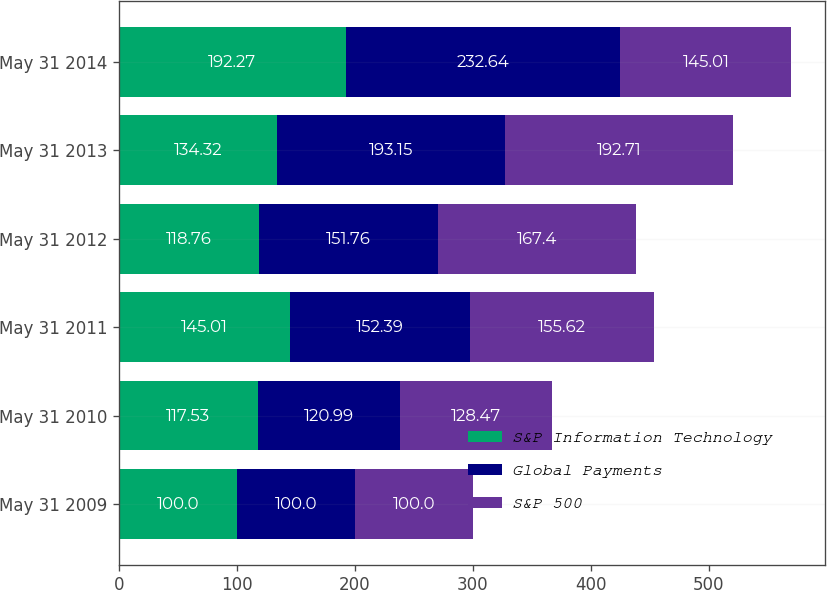<chart> <loc_0><loc_0><loc_500><loc_500><stacked_bar_chart><ecel><fcel>May 31 2009<fcel>May 31 2010<fcel>May 31 2011<fcel>May 31 2012<fcel>May 31 2013<fcel>May 31 2014<nl><fcel>S&P Information Technology<fcel>100<fcel>117.53<fcel>145.01<fcel>118.76<fcel>134.32<fcel>192.27<nl><fcel>Global Payments<fcel>100<fcel>120.99<fcel>152.39<fcel>151.76<fcel>193.15<fcel>232.64<nl><fcel>S&P 500<fcel>100<fcel>128.47<fcel>155.62<fcel>167.4<fcel>192.71<fcel>145.01<nl></chart> 